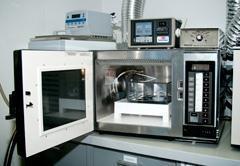How many microwaves?
Give a very brief answer. 1. How many men are in the picture?
Give a very brief answer. 0. 